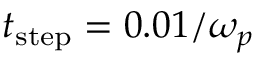<formula> <loc_0><loc_0><loc_500><loc_500>t _ { s t e p } = 0 . 0 1 / \omega _ { p }</formula> 